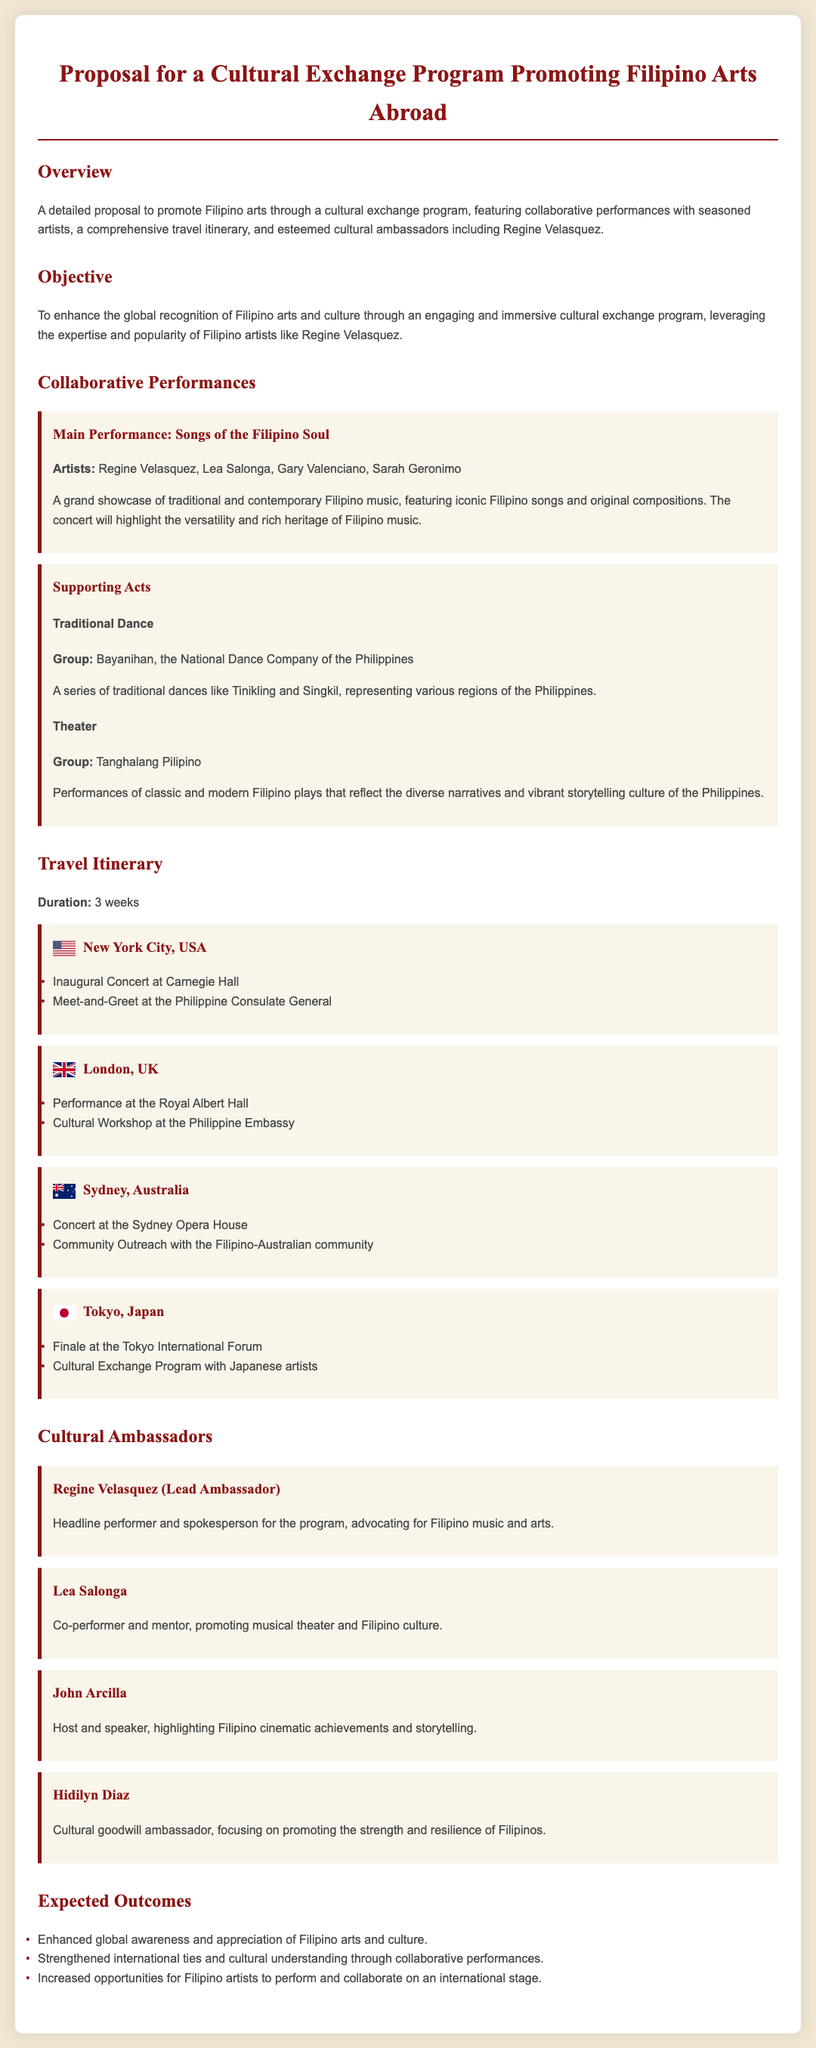what is the title of the proposal? The title of the proposal is the heading of the document, which indicates the purpose of the content.
Answer: Proposal for a Cultural Exchange Program Promoting Filipino Arts Abroad who is the lead ambassador mentioned in the proposal? The lead ambassador is identified in the section discussing cultural ambassadors.
Answer: Regine Velasquez what is the duration of the travel itinerary? The duration specified in the travel itinerary section indicates how long the program will take.
Answer: 3 weeks which city will host the final performance? The final performance city is mentioned in the travel itinerary section detailing events in various locations.
Answer: Tokyo name one supporting act for the main performance. A supporting act is presented under the collaborative performances section, highlighting contributions to the main event.
Answer: Bayanihan, the National Dance Company of the Philippines what is one expected outcome of the program? Expected outcomes are listed in the section outlining the intended results of the cultural exchange program.
Answer: Enhanced global awareness and appreciation of Filipino arts and culture which venue is mentioned for the inaugural concert? The venue for the inaugural concert is detailed in the New York City part of the travel itinerary.
Answer: Carnegie Hall which Filipino artist is recognized for promoting musical theater? The artist known for this role is mentioned under the cultural ambassadors section, reflecting their contributions to the arts.
Answer: Lea Salonga 